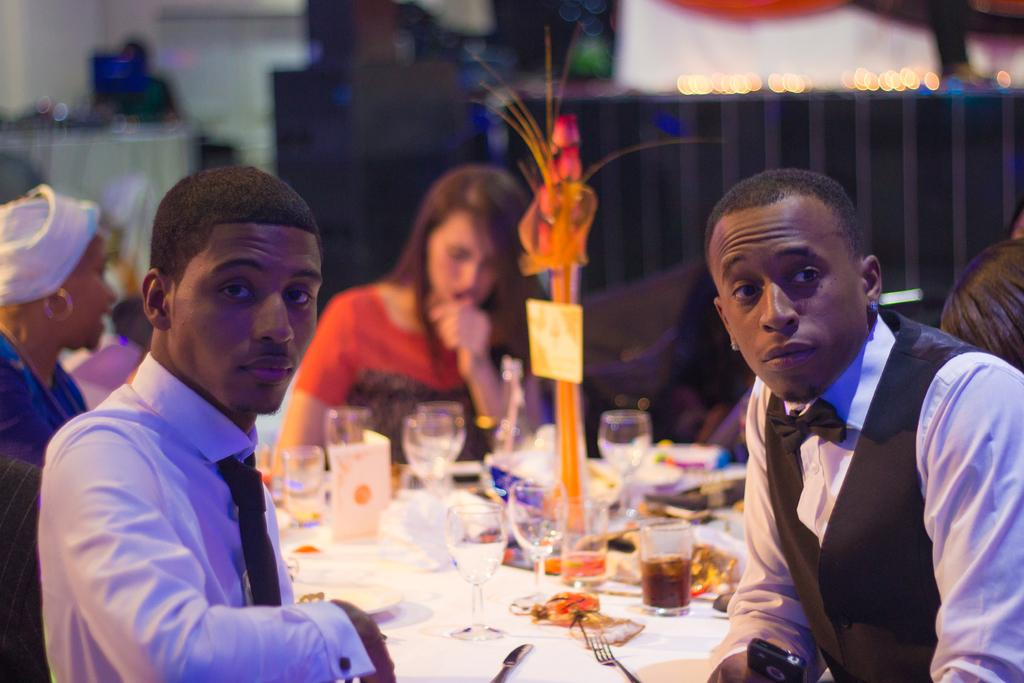What are the people in the image doing? The people in the image are sitting around a table. What objects can be seen on the table? There are glasses, a fork, and a knife on the table. What type of plant is growing in the middle of the table in the image? There is no plant growing in the middle of the table in the image. 